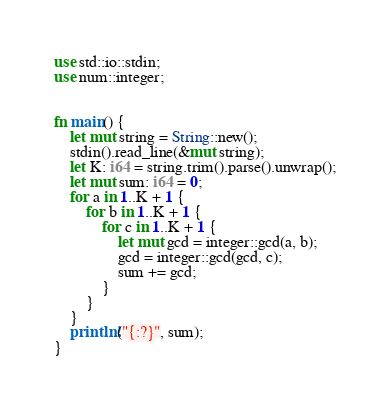Convert code to text. <code><loc_0><loc_0><loc_500><loc_500><_Rust_>use std::io::stdin;
use num::integer;


fn main() {
    let mut string = String::new();
    stdin().read_line(&mut string);
    let K: i64 = string.trim().parse().unwrap();
    let mut sum: i64 = 0;
    for a in 1..K + 1 {
        for b in 1..K + 1 {
            for c in 1..K + 1 {
                let mut gcd = integer::gcd(a, b);
                gcd = integer::gcd(gcd, c);
                sum += gcd;
            }
        }
    }
    println!("{:?}", sum);
}
</code> 